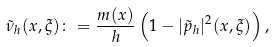Convert formula to latex. <formula><loc_0><loc_0><loc_500><loc_500>\tilde { \nu } _ { h } ( x , \xi ) \colon = \frac { m ( x ) } { h } \left ( 1 - | \tilde { p } _ { h } | ^ { 2 } ( x , \xi ) \right ) ,</formula> 